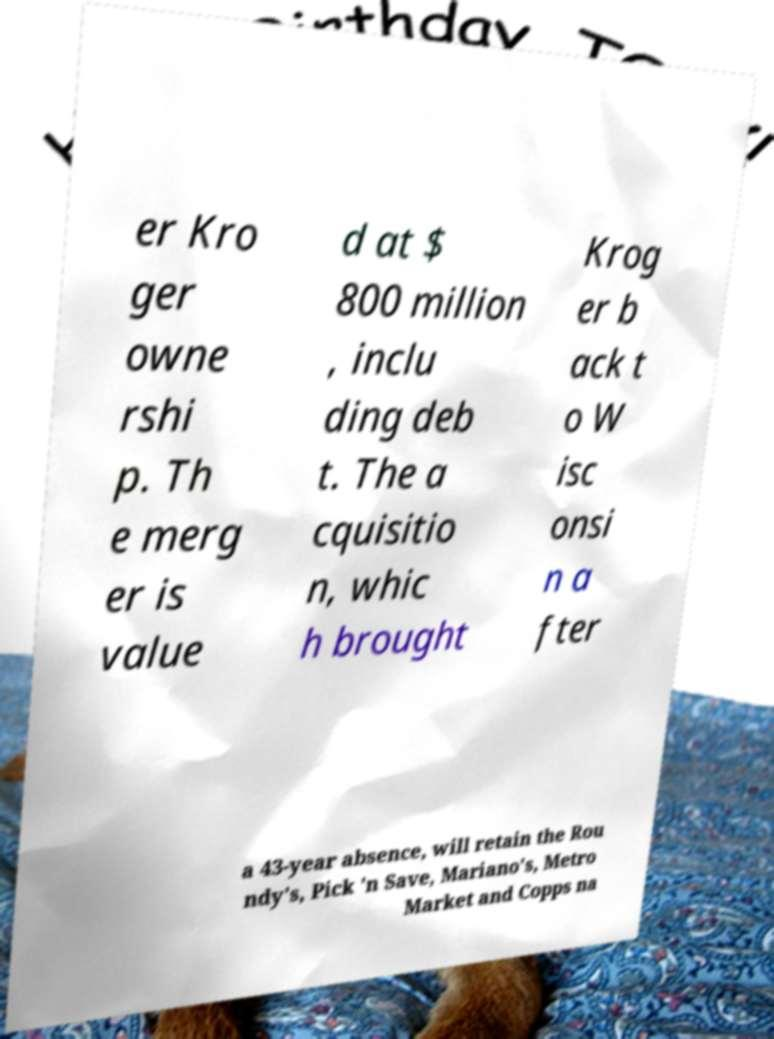Can you accurately transcribe the text from the provided image for me? er Kro ger owne rshi p. Th e merg er is value d at $ 800 million , inclu ding deb t. The a cquisitio n, whic h brought Krog er b ack t o W isc onsi n a fter a 43-year absence, will retain the Rou ndy's, Pick 'n Save, Mariano's, Metro Market and Copps na 